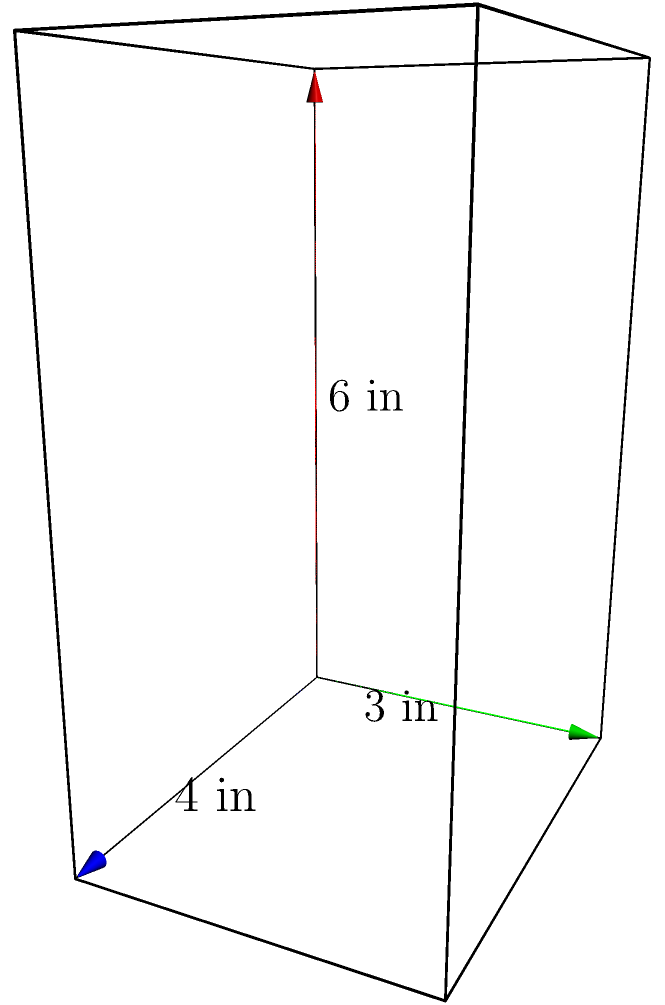While grocery shopping with your kids, you decide to make it fun by turning it into a math game. You pick up a box of their favorite cereal, which is shaped like a rectangular prism. The box measures 4 inches in width, 3 inches in depth, and 6 inches in height. What is the volume of this cereal box in cubic inches? To find the volume of a rectangular prism, we need to multiply its length, width, and height. Let's break it down step-by-step:

1. Identify the dimensions:
   - Width (w) = 4 inches
   - Depth (d) = 3 inches
   - Height (h) = 6 inches

2. Apply the formula for the volume of a rectangular prism:
   $$ V = w \times d \times h $$

3. Substitute the values into the formula:
   $$ V = 4 \text{ in} \times 3 \text{ in} \times 6 \text{ in} $$

4. Multiply the numbers:
   $$ V = 72 \text{ in}^3 $$

Therefore, the volume of the cereal box is 72 cubic inches.
Answer: 72 in³ 